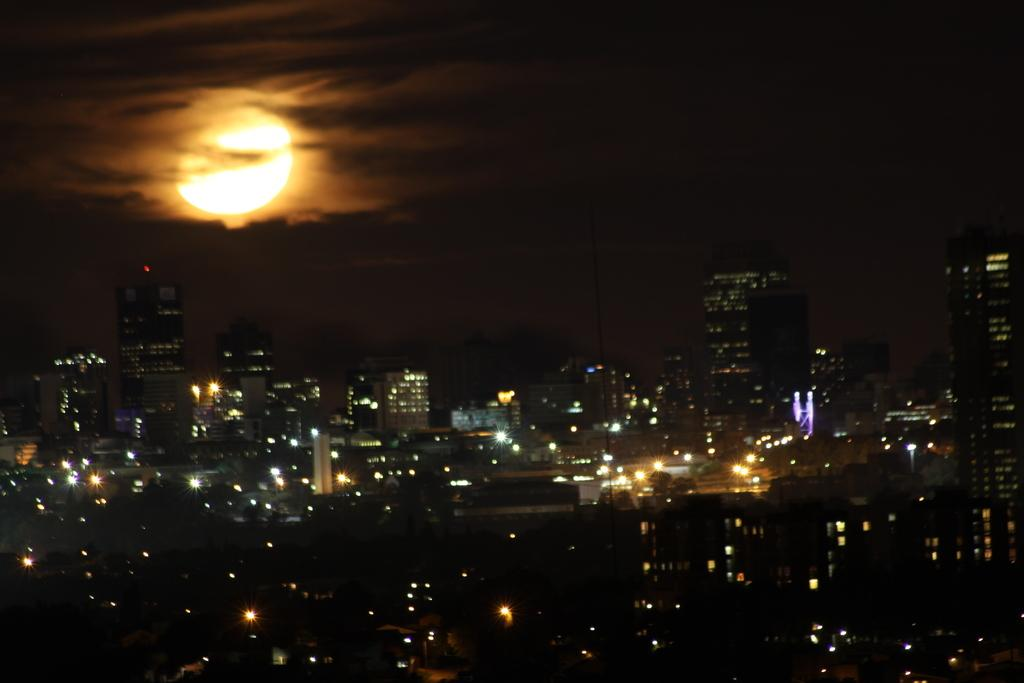What is located in the middle of the image? There are buildings in the middle of the image. What celestial body can be seen in the sky at the top of the image? The moon is visible in the sky at the top of the image. What type of leather is being used to make the bottle in the image? There is no bottle or leather present in the image. What is located in the middle of the image, besides the buildings? There are no other objects or subjects located in the middle of the image besides the buildings. 